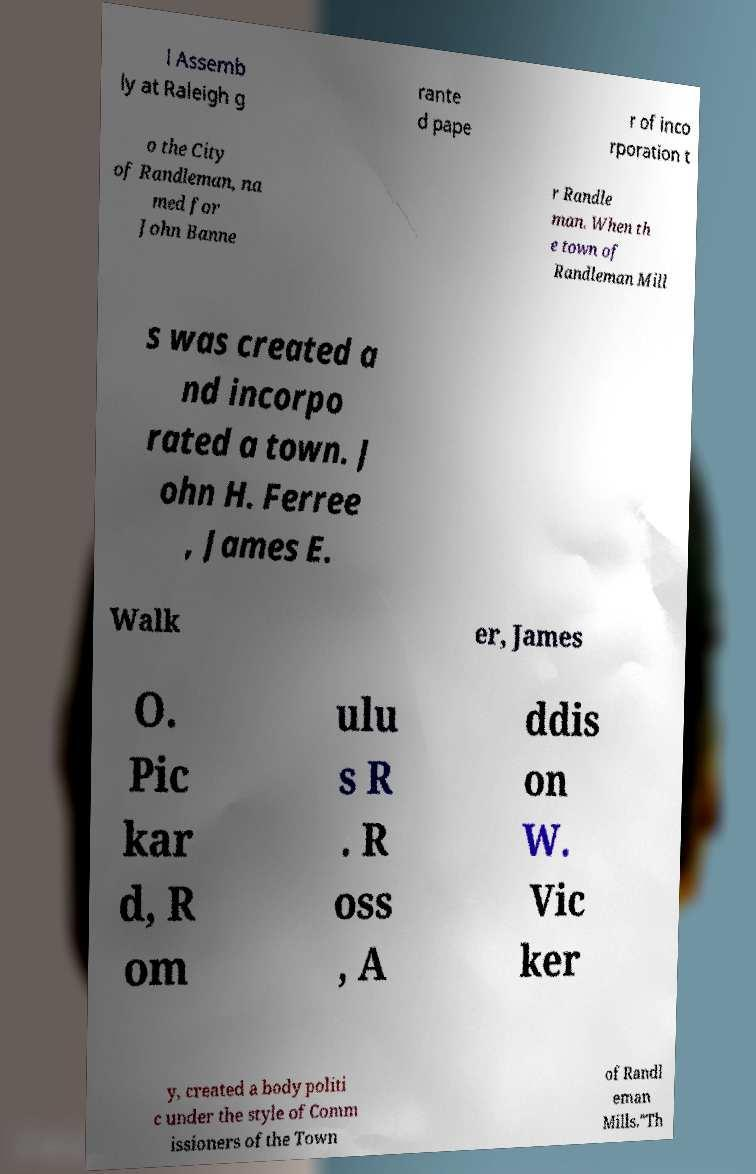Can you read and provide the text displayed in the image?This photo seems to have some interesting text. Can you extract and type it out for me? l Assemb ly at Raleigh g rante d pape r of inco rporation t o the City of Randleman, na med for John Banne r Randle man. When th e town of Randleman Mill s was created a nd incorpo rated a town. J ohn H. Ferree , James E. Walk er, James O. Pic kar d, R om ulu s R . R oss , A ddis on W. Vic ker y, created a body politi c under the style of Comm issioners of the Town of Randl eman Mills."Th 